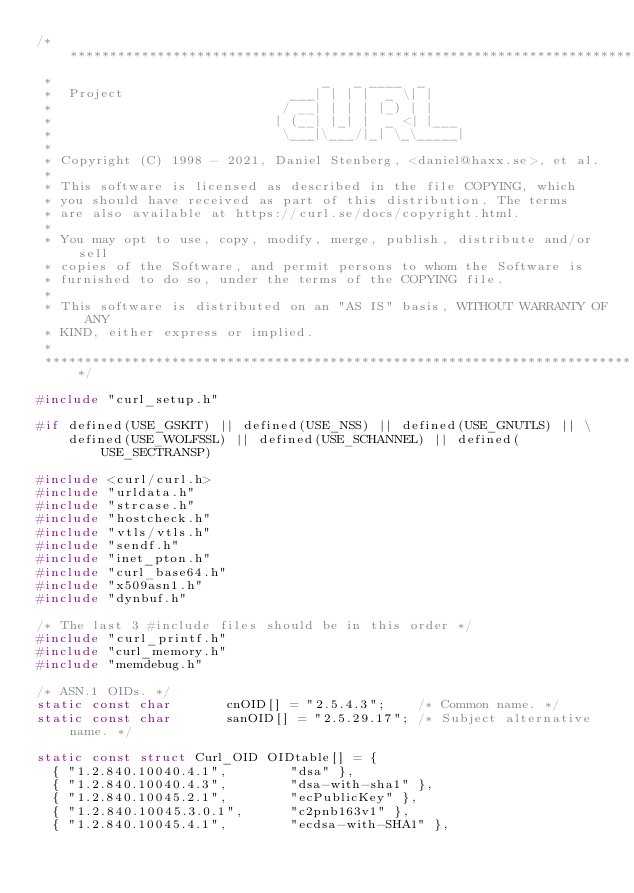<code> <loc_0><loc_0><loc_500><loc_500><_C_>/***************************************************************************
 *                                  _   _ ____  _
 *  Project                     ___| | | |  _ \| |
 *                             / __| | | | |_) | |
 *                            | (__| |_| |  _ <| |___
 *                             \___|\___/|_| \_\_____|
 *
 * Copyright (C) 1998 - 2021, Daniel Stenberg, <daniel@haxx.se>, et al.
 *
 * This software is licensed as described in the file COPYING, which
 * you should have received as part of this distribution. The terms
 * are also available at https://curl.se/docs/copyright.html.
 *
 * You may opt to use, copy, modify, merge, publish, distribute and/or sell
 * copies of the Software, and permit persons to whom the Software is
 * furnished to do so, under the terms of the COPYING file.
 *
 * This software is distributed on an "AS IS" basis, WITHOUT WARRANTY OF ANY
 * KIND, either express or implied.
 *
 ***************************************************************************/

#include "curl_setup.h"

#if defined(USE_GSKIT) || defined(USE_NSS) || defined(USE_GNUTLS) || \
    defined(USE_WOLFSSL) || defined(USE_SCHANNEL) || defined(USE_SECTRANSP)

#include <curl/curl.h>
#include "urldata.h"
#include "strcase.h"
#include "hostcheck.h"
#include "vtls/vtls.h"
#include "sendf.h"
#include "inet_pton.h"
#include "curl_base64.h"
#include "x509asn1.h"
#include "dynbuf.h"

/* The last 3 #include files should be in this order */
#include "curl_printf.h"
#include "curl_memory.h"
#include "memdebug.h"

/* ASN.1 OIDs. */
static const char       cnOID[] = "2.5.4.3";    /* Common name. */
static const char       sanOID[] = "2.5.29.17"; /* Subject alternative name. */

static const struct Curl_OID OIDtable[] = {
  { "1.2.840.10040.4.1",        "dsa" },
  { "1.2.840.10040.4.3",        "dsa-with-sha1" },
  { "1.2.840.10045.2.1",        "ecPublicKey" },
  { "1.2.840.10045.3.0.1",      "c2pnb163v1" },
  { "1.2.840.10045.4.1",        "ecdsa-with-SHA1" },</code> 